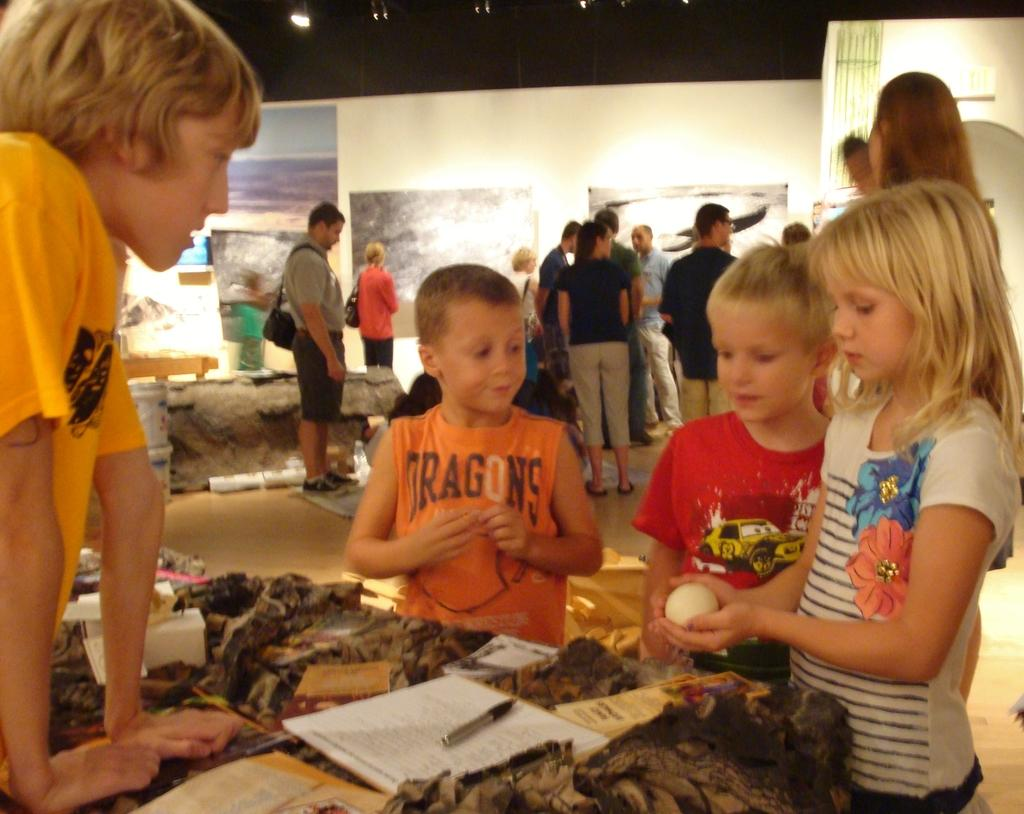How many people are in the image? There is a group of people in the image. What can be seen in the image besides the people? There is a cloth, books, a marker, and a wall with posters in the background of the image. What is the source of light in the background of the image? There is a light in the background of the image. What type of driving is being discussed in the image? There is no driving present in the image; it features a group of people, cloth, books, a marker, and a wall with posters. What is the title of the book being read by the person in the image? There is no person reading a book in the image, and therefore no title can be determined. 